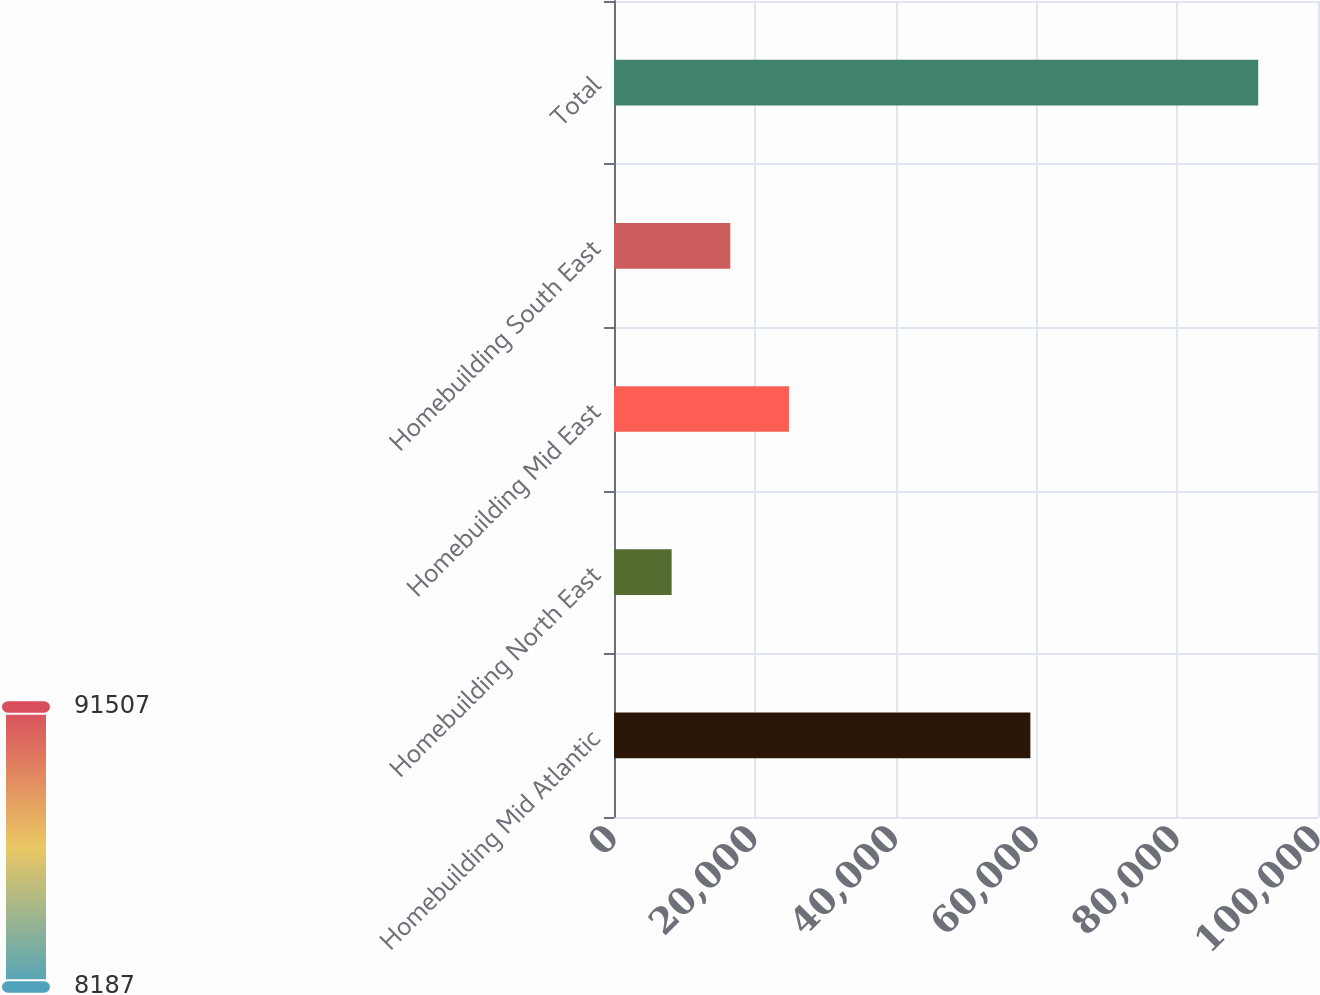Convert chart to OTSL. <chart><loc_0><loc_0><loc_500><loc_500><bar_chart><fcel>Homebuilding Mid Atlantic<fcel>Homebuilding North East<fcel>Homebuilding Mid East<fcel>Homebuilding South East<fcel>Total<nl><fcel>59144<fcel>8187<fcel>24851<fcel>16519<fcel>91507<nl></chart> 